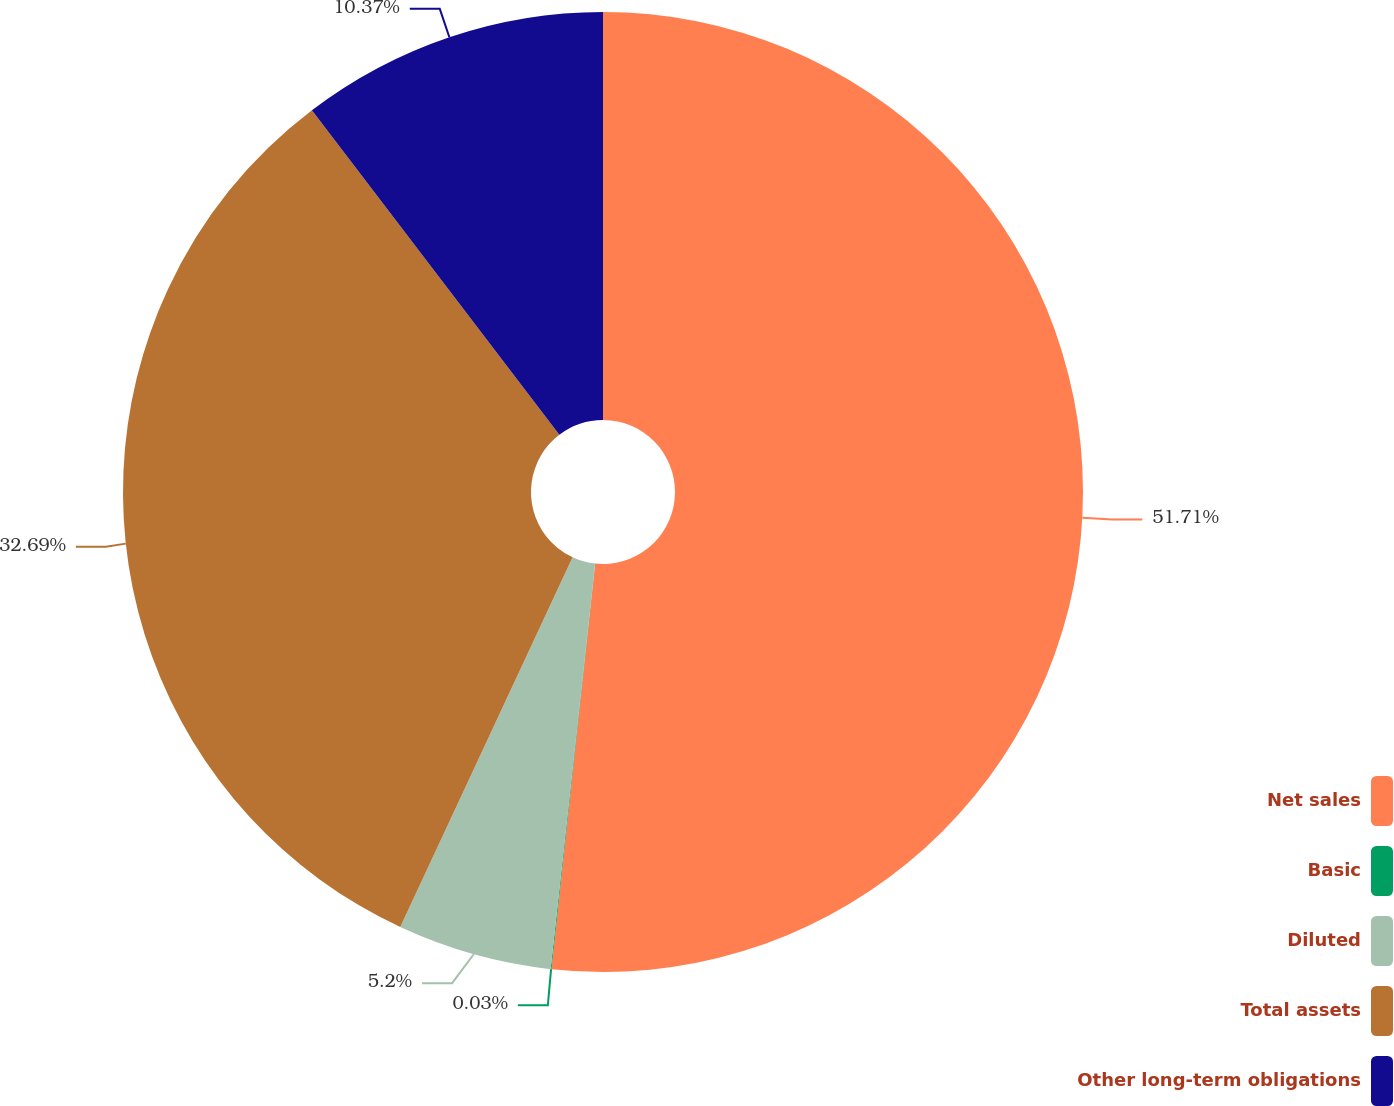<chart> <loc_0><loc_0><loc_500><loc_500><pie_chart><fcel>Net sales<fcel>Basic<fcel>Diluted<fcel>Total assets<fcel>Other long-term obligations<nl><fcel>51.71%<fcel>0.03%<fcel>5.2%<fcel>32.69%<fcel>10.37%<nl></chart> 